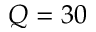<formula> <loc_0><loc_0><loc_500><loc_500>Q = 3 0</formula> 